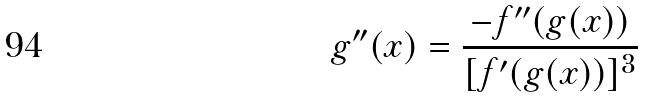<formula> <loc_0><loc_0><loc_500><loc_500>g ^ { \prime \prime } ( x ) = \frac { - f ^ { \prime \prime } ( g ( x ) ) } { [ f ^ { \prime } ( g ( x ) ) ] ^ { 3 } }</formula> 